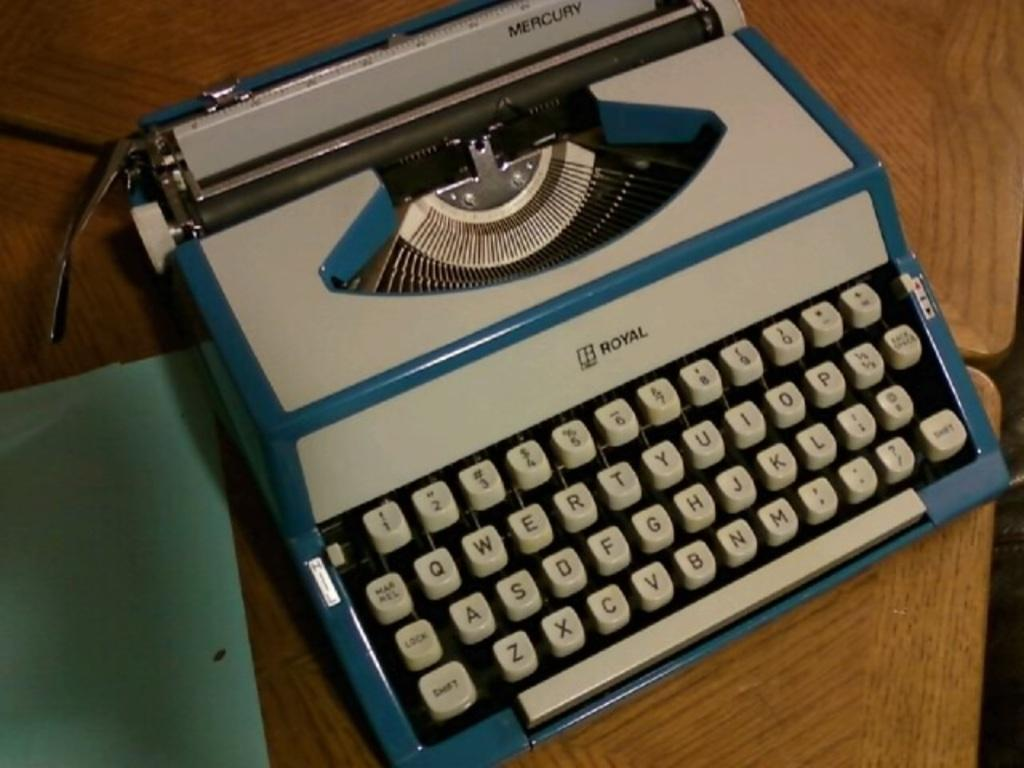<image>
Create a compact narrative representing the image presented. White and blue typewriter with the word ROYAL on it. 